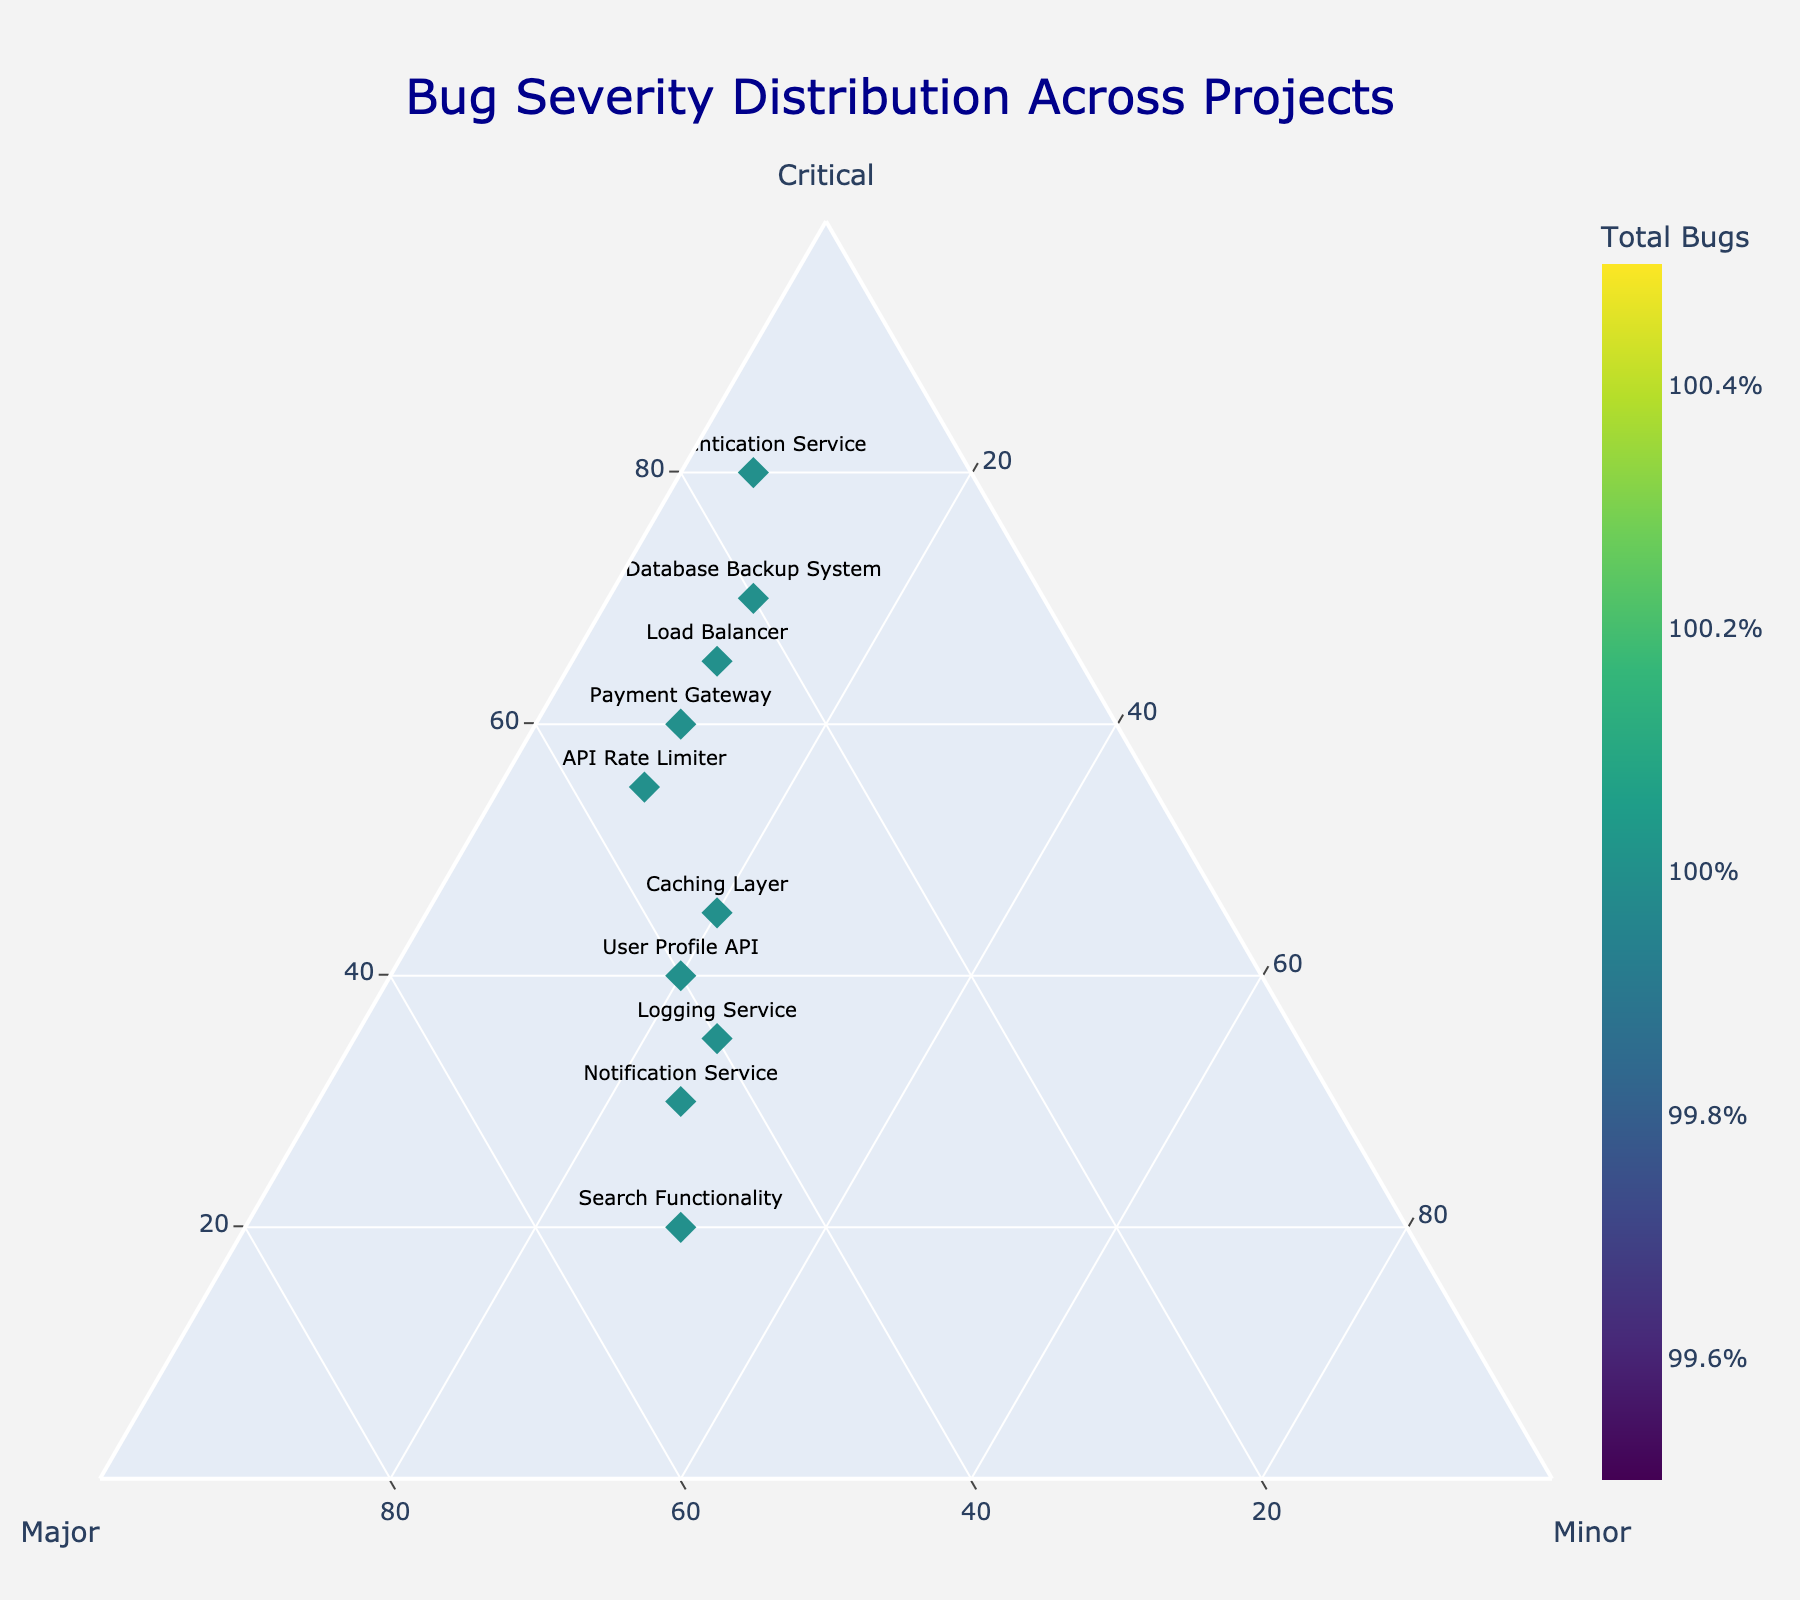How many data points (projects) are shown on the plot? By counting the number of markers (one for each project) on the ternary plot, we can determine the number of data points.
Answer: 10 What is the title of the plot? The title is located at the top center of the plot and is indicated in a large font.
Answer: Bug Severity Distribution Across Projects Which project has the highest percentage of critical bugs? We need to look at the markers at the top vertex of the triangle (Critical axis). The marker closest to the top will have the highest percentage of critical bugs.
Answer: Authentication Service Which project has the most balanced distribution of bug severities (i.e., similar percentages for Critical, Major, and Minor)? This marker will be closest to the center of the ternary plot, indicating similar percentages across all three bug severities.
Answer: User Profile API Which project has the highest total number of bugs? By looking at the color gradient on the markers, the project with the darkest marker represents the highest total number of bugs. The color bar on the right provides a guide for this.
Answer: Authentication Service What's the average percentage of major bugs among all projects? The Major axis percentages for all projects need to be summed and then divided by the number of projects. (15 + 30 + 40 + 50 + 20 + 45 + 35 + 35 + 25 + 40) / 10 = 33.5%
Answer: 33.5% Compare the Distribution of Minor bugs between the Search Functionality and Load Balancer projects. For Search Functionality: Minor bugs percentage is 30%. For Load Balancer: Minor bugs percentage is 10%. Therefore, Search Functionality has a higher percentage of minor bugs.
Answer: Search Functionality Which project has the lowest percentage of major bugs but more than 70 Critical bugs? First, identify projects with more than 70 Critical bugs, then compare their percentages of major bugs to find the lowest. The candidate projects are Authentication Service (15% Major) and Database Backup System (20% Major).
Answer: Authentication Service How many projects have a proportion of Major bugs between 30% and 50%? By identifying markers within the specified range on the Major axis, we count the qualifying projects. Projects are Payment Gateway, User Profile API, Search Functionality, Notification Service, API Rate Limiter, Caching Layer, and Logging Service.
Answer: 7 What is the minor bug percentage for the project with the second-highest total number of bugs? Identify the project with the second darkest marker color according to the color bar. The Load Balancer project has the second-highest total number of bugs. The minor bug percentage for Load Balancer is 10%.
Answer: 10% 